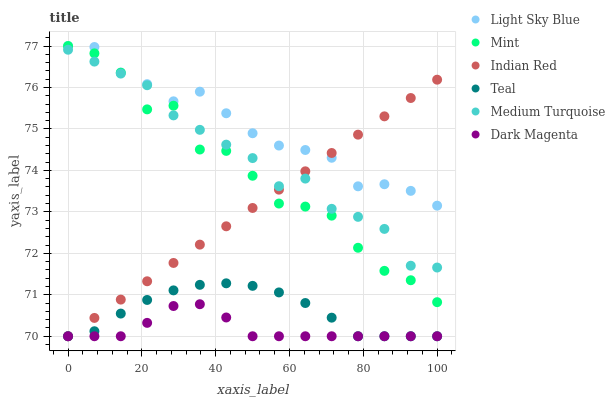Does Dark Magenta have the minimum area under the curve?
Answer yes or no. Yes. Does Light Sky Blue have the maximum area under the curve?
Answer yes or no. Yes. Does Medium Turquoise have the minimum area under the curve?
Answer yes or no. No. Does Medium Turquoise have the maximum area under the curve?
Answer yes or no. No. Is Indian Red the smoothest?
Answer yes or no. Yes. Is Mint the roughest?
Answer yes or no. Yes. Is Light Sky Blue the smoothest?
Answer yes or no. No. Is Light Sky Blue the roughest?
Answer yes or no. No. Does Teal have the lowest value?
Answer yes or no. Yes. Does Medium Turquoise have the lowest value?
Answer yes or no. No. Does Mint have the highest value?
Answer yes or no. Yes. Does Medium Turquoise have the highest value?
Answer yes or no. No. Is Dark Magenta less than Medium Turquoise?
Answer yes or no. Yes. Is Medium Turquoise greater than Dark Magenta?
Answer yes or no. Yes. Does Medium Turquoise intersect Mint?
Answer yes or no. Yes. Is Medium Turquoise less than Mint?
Answer yes or no. No. Is Medium Turquoise greater than Mint?
Answer yes or no. No. Does Dark Magenta intersect Medium Turquoise?
Answer yes or no. No. 